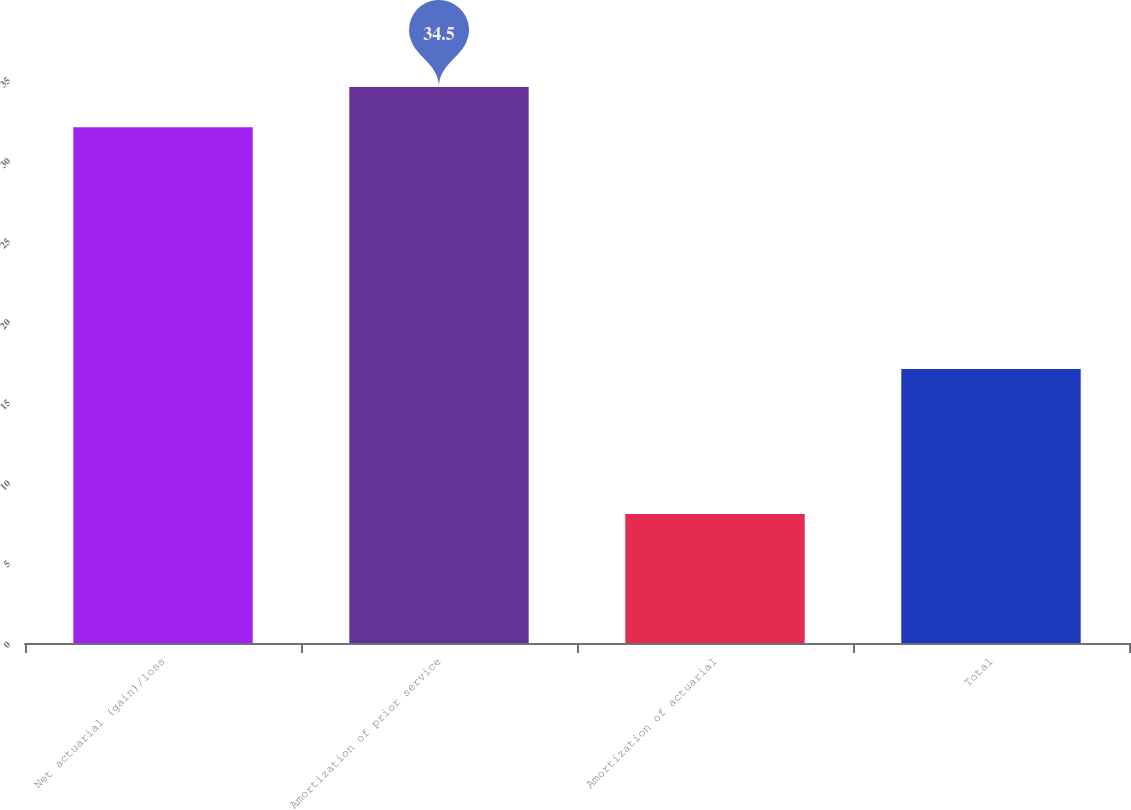<chart> <loc_0><loc_0><loc_500><loc_500><bar_chart><fcel>Net actuarial (gain)/loss<fcel>Amortization of prior service<fcel>Amortization of actuarial<fcel>Total<nl><fcel>32<fcel>34.5<fcel>8<fcel>17<nl></chart> 